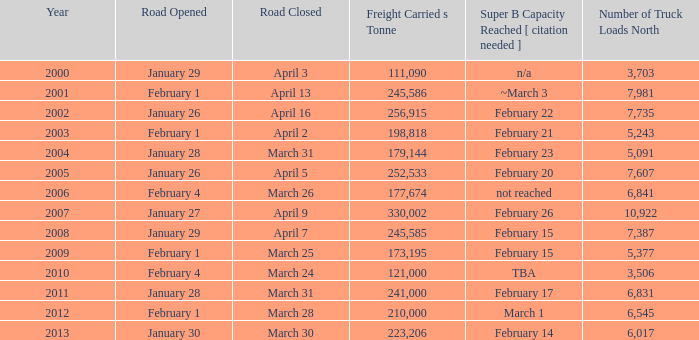What is the minimum quantity of cargo transported on the road that shut down on march 31 and attained super b capacity on february 17 post 2011? None. 